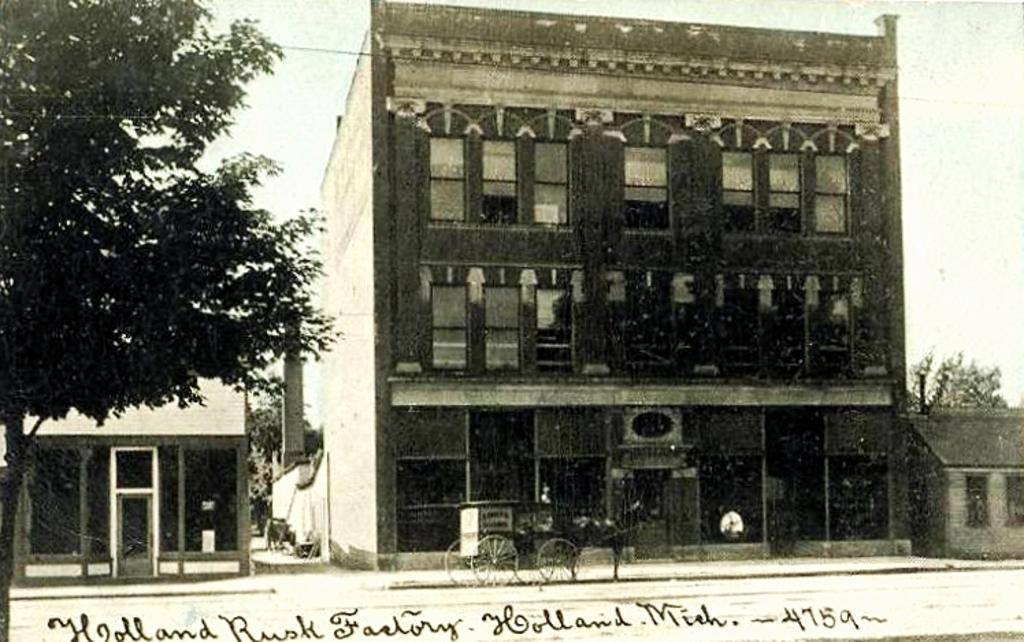Could you give a brief overview of what you see in this image? In this image we can see buildings, horse cart, sky, electric cable and trees. 